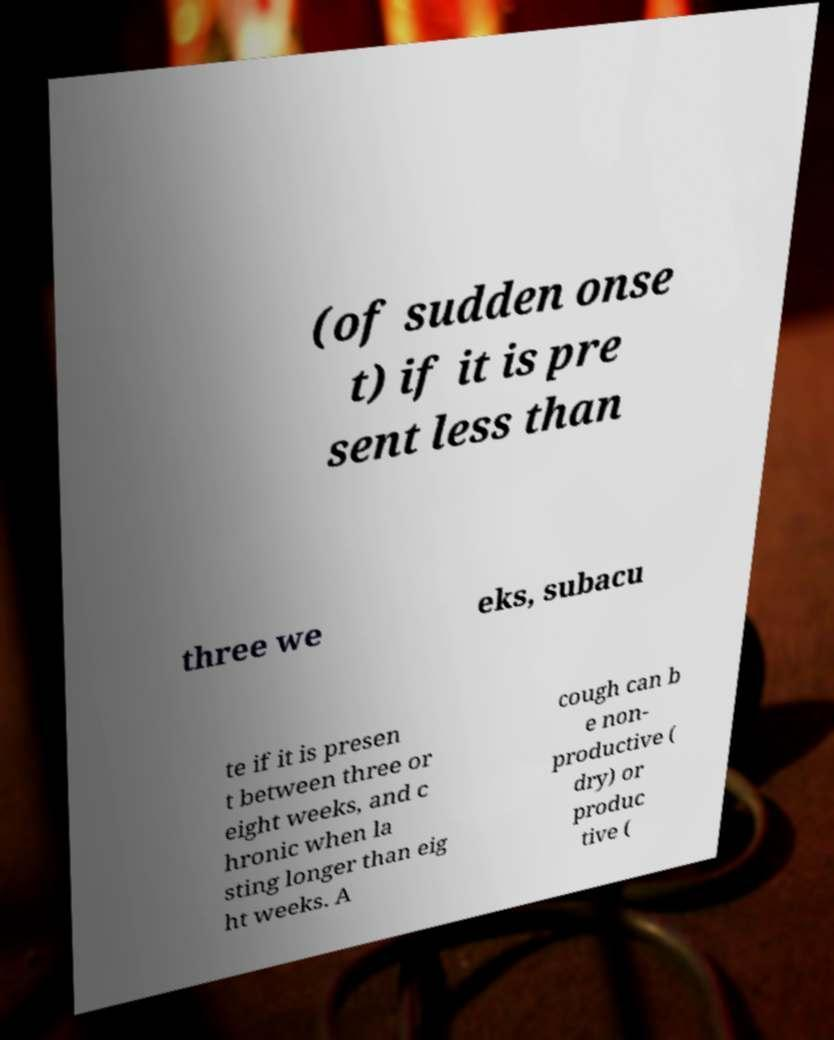Can you accurately transcribe the text from the provided image for me? (of sudden onse t) if it is pre sent less than three we eks, subacu te if it is presen t between three or eight weeks, and c hronic when la sting longer than eig ht weeks. A cough can b e non- productive ( dry) or produc tive ( 